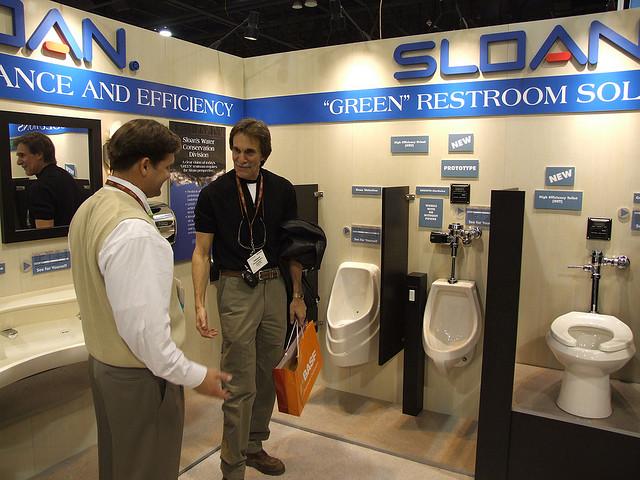Is the man in the black shirt carrying a shopping bag?
Answer briefly. Yes. How many toilets are in view?
Quick response, please. 1. How many men are present?
Give a very brief answer. 2. 